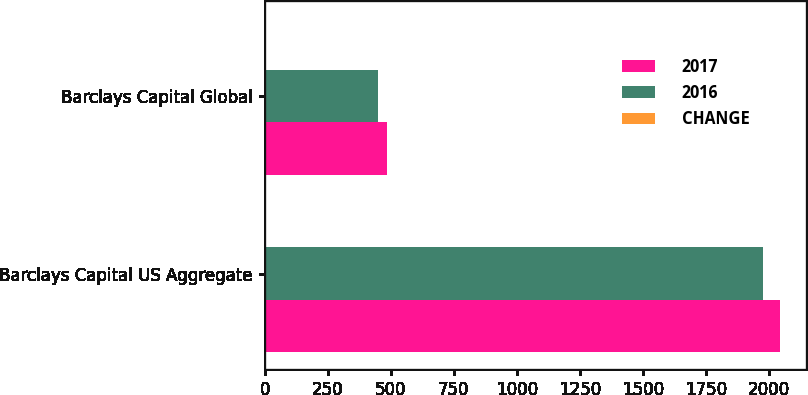Convert chart to OTSL. <chart><loc_0><loc_0><loc_500><loc_500><stacked_bar_chart><ecel><fcel>Barclays Capital US Aggregate<fcel>Barclays Capital Global<nl><fcel>2017<fcel>2046<fcel>485<nl><fcel>2016<fcel>1976<fcel>451<nl><fcel>CHANGE<fcel>4<fcel>7<nl></chart> 